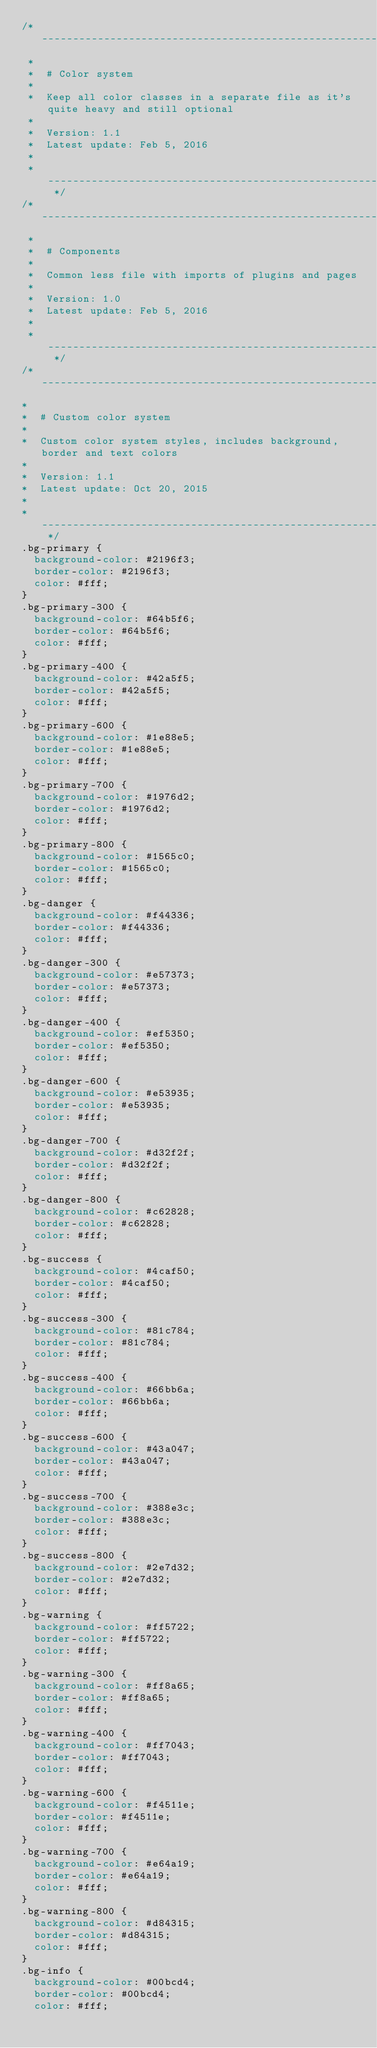Convert code to text. <code><loc_0><loc_0><loc_500><loc_500><_CSS_>/* ------------------------------------------------------------------------------
 *
 *  # Color system
 *
 *  Keep all color classes in a separate file as it's quite heavy and still optional
 *
 *  Version: 1.1
 *  Latest update: Feb 5, 2016
 *
 * ---------------------------------------------------------------------------- */
/* ------------------------------------------------------------------------------
 *
 *  # Components
 *
 *  Common less file with imports of plugins and pages
 *
 *  Version: 1.0
 *  Latest update: Feb 5, 2016
 *
 * ---------------------------------------------------------------------------- */
/* ------------------------------------------------------------------------------
*
*  # Custom color system
*
*  Custom color system styles, includes background, border and text colors
*
*  Version: 1.1
*  Latest update: Oct 20, 2015
*
* ---------------------------------------------------------------------------- */
.bg-primary {
  background-color: #2196f3;
  border-color: #2196f3;
  color: #fff;
}
.bg-primary-300 {
  background-color: #64b5f6;
  border-color: #64b5f6;
  color: #fff;
}
.bg-primary-400 {
  background-color: #42a5f5;
  border-color: #42a5f5;
  color: #fff;
}
.bg-primary-600 {
  background-color: #1e88e5;
  border-color: #1e88e5;
  color: #fff;
}
.bg-primary-700 {
  background-color: #1976d2;
  border-color: #1976d2;
  color: #fff;
}
.bg-primary-800 {
  background-color: #1565c0;
  border-color: #1565c0;
  color: #fff;
}
.bg-danger {
  background-color: #f44336;
  border-color: #f44336;
  color: #fff;
}
.bg-danger-300 {
  background-color: #e57373;
  border-color: #e57373;
  color: #fff;
}
.bg-danger-400 {
  background-color: #ef5350;
  border-color: #ef5350;
  color: #fff;
}
.bg-danger-600 {
  background-color: #e53935;
  border-color: #e53935;
  color: #fff;
}
.bg-danger-700 {
  background-color: #d32f2f;
  border-color: #d32f2f;
  color: #fff;
}
.bg-danger-800 {
  background-color: #c62828;
  border-color: #c62828;
  color: #fff;
}
.bg-success {
  background-color: #4caf50;
  border-color: #4caf50;
  color: #fff;
}
.bg-success-300 {
  background-color: #81c784;
  border-color: #81c784;
  color: #fff;
}
.bg-success-400 {
  background-color: #66bb6a;
  border-color: #66bb6a;
  color: #fff;
}
.bg-success-600 {
  background-color: #43a047;
  border-color: #43a047;
  color: #fff;
}
.bg-success-700 {
  background-color: #388e3c;
  border-color: #388e3c;
  color: #fff;
}
.bg-success-800 {
  background-color: #2e7d32;
  border-color: #2e7d32;
  color: #fff;
}
.bg-warning {
  background-color: #ff5722;
  border-color: #ff5722;
  color: #fff;
}
.bg-warning-300 {
  background-color: #ff8a65;
  border-color: #ff8a65;
  color: #fff;
}
.bg-warning-400 {
  background-color: #ff7043;
  border-color: #ff7043;
  color: #fff;
}
.bg-warning-600 {
  background-color: #f4511e;
  border-color: #f4511e;
  color: #fff;
}
.bg-warning-700 {
  background-color: #e64a19;
  border-color: #e64a19;
  color: #fff;
}
.bg-warning-800 {
  background-color: #d84315;
  border-color: #d84315;
  color: #fff;
}
.bg-info {
  background-color: #00bcd4;
  border-color: #00bcd4;
  color: #fff;</code> 